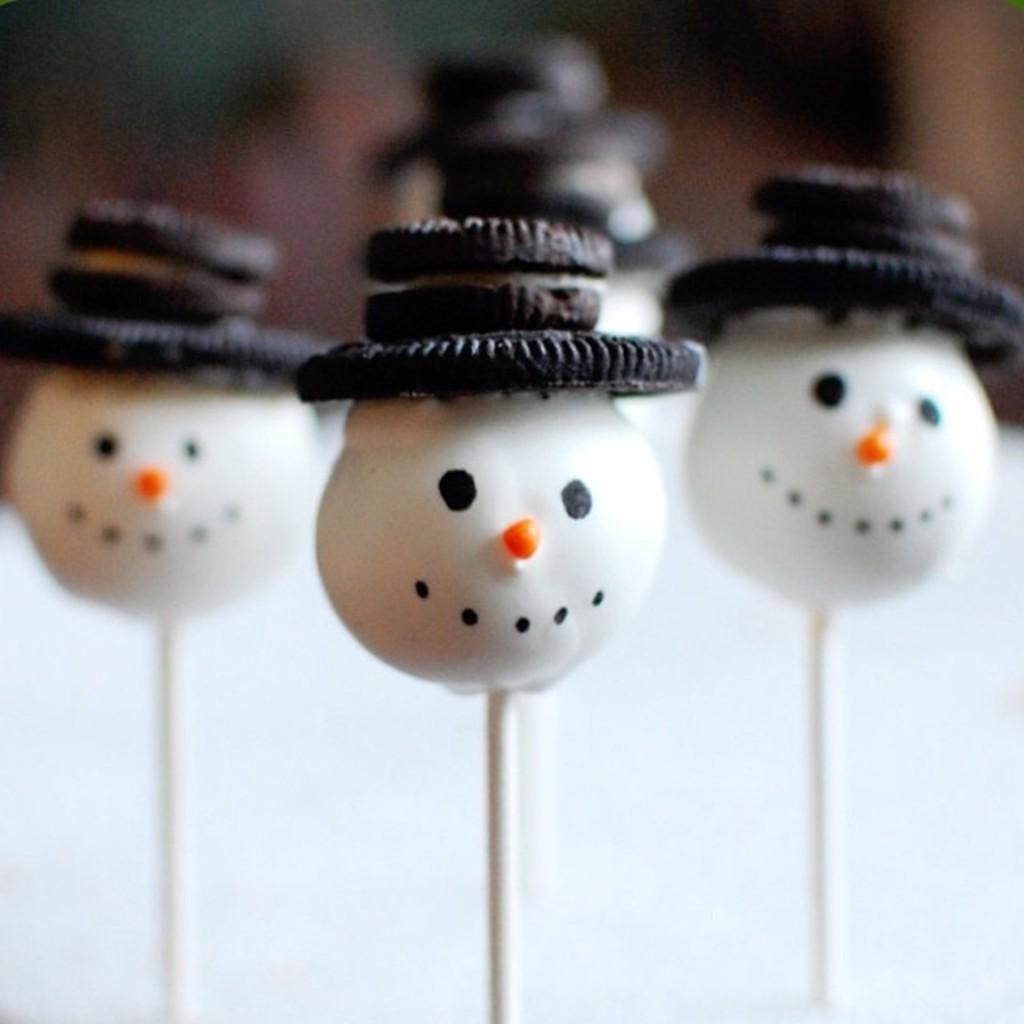How would you summarize this image in a sentence or two? In this image, we can see some lollipops. 